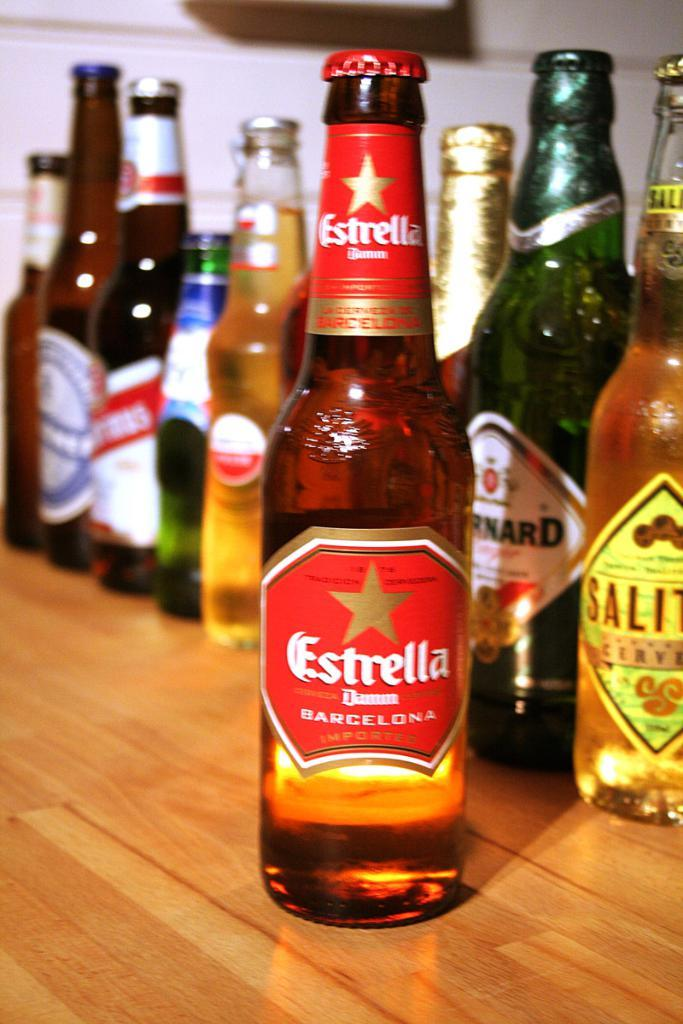What type of containers are visible in the image? There are glass bottles in the image. Where are the glass bottles located? The glass bottles are placed on a table. What can be seen in the background of the image? There is a wall in the background of the image. What type of snail can be seen crawling on the ground in the image? There is no snail present in the image, and the ground is not visible in the image. 